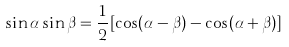Convert formula to latex. <formula><loc_0><loc_0><loc_500><loc_500>\sin \alpha \sin \beta = \frac { 1 } { 2 } [ \cos ( \alpha - \beta ) - \cos ( \alpha + \beta ) ]</formula> 